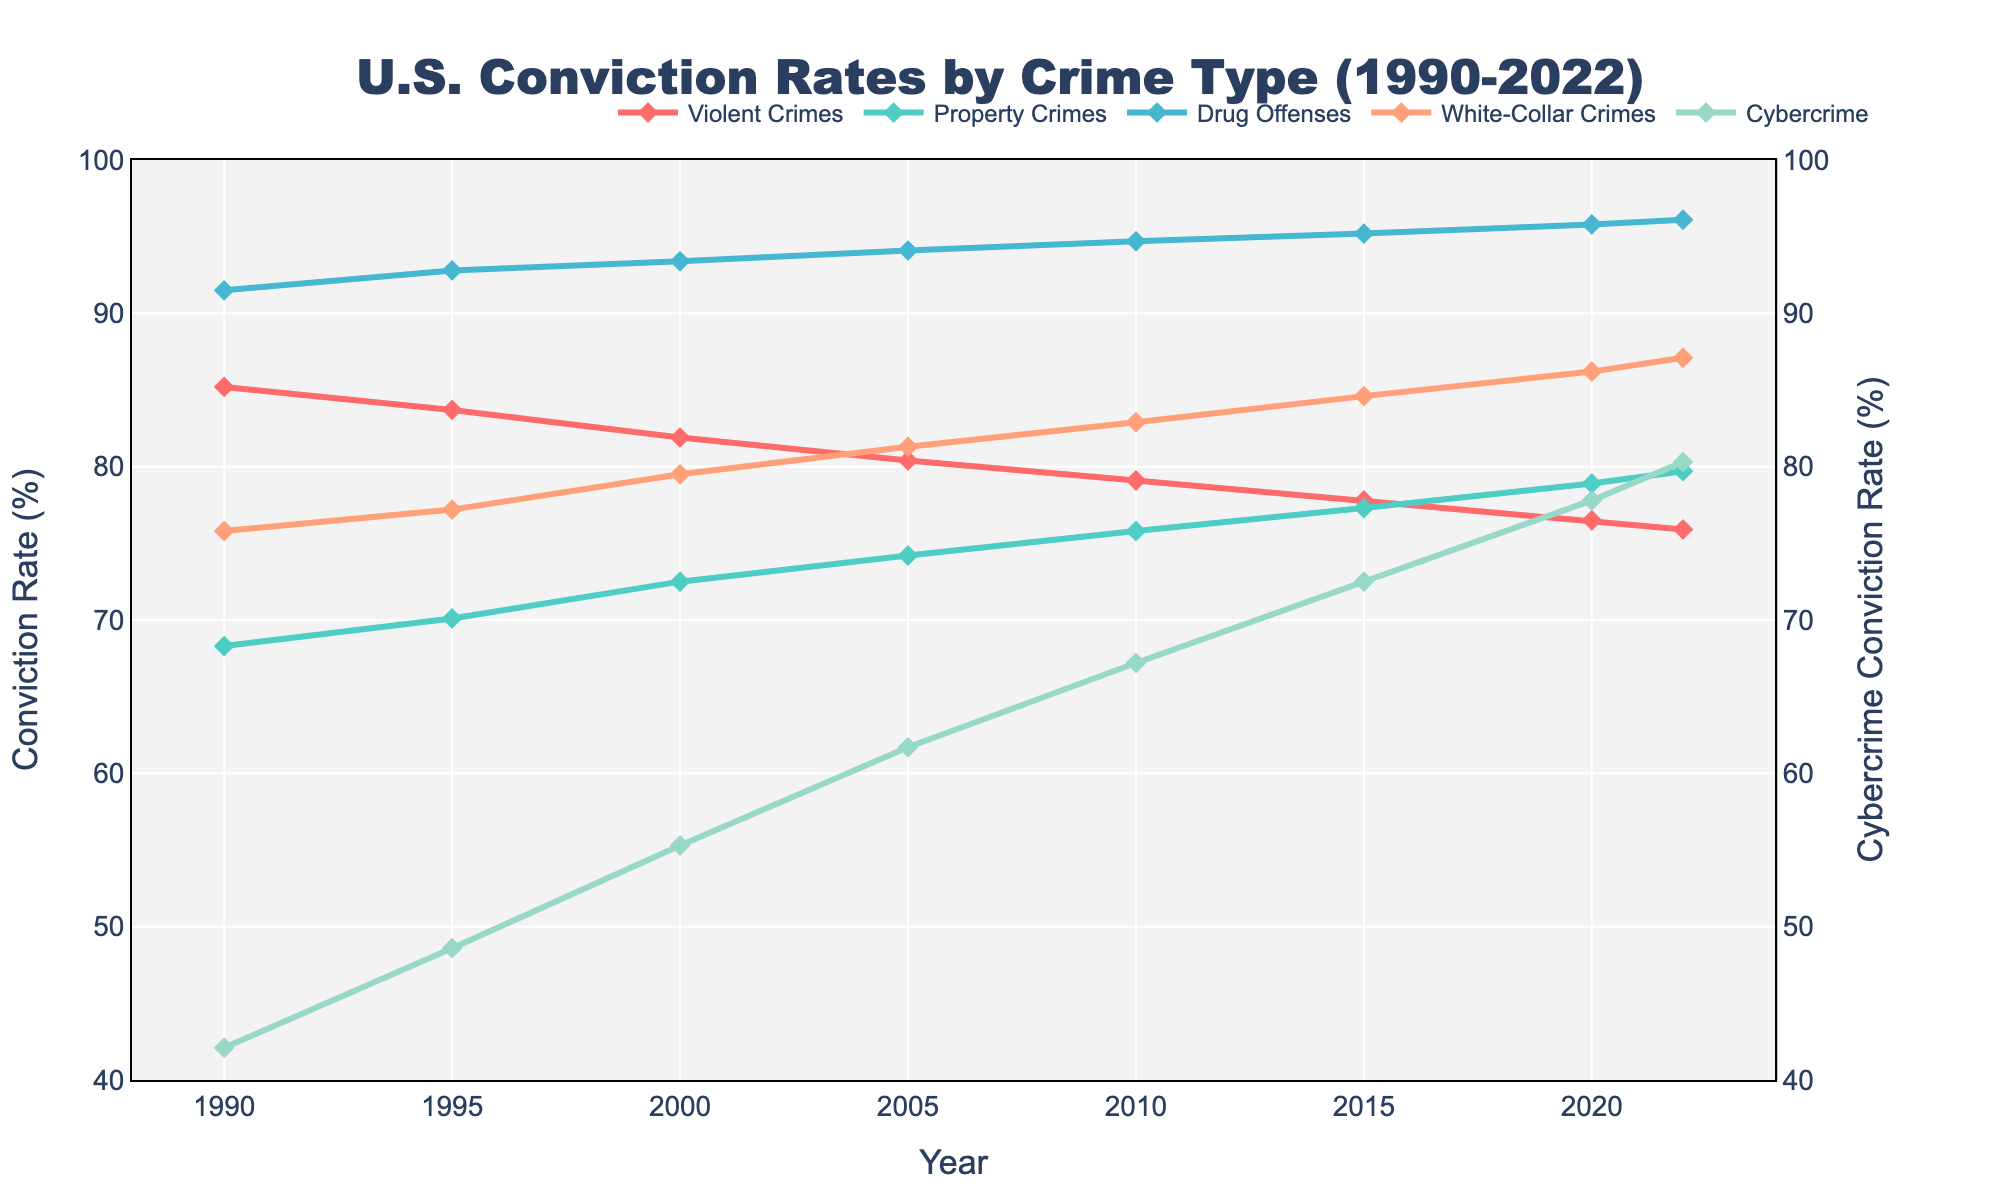How has the conviction rate for violent crimes changed from 1990 to 2022? From the chart, locate the line representing violent crimes and observe the change in height from the year 1990 to the year 2022. The rate starts at 85.2% in 1990 and gradually decreases to 75.9% in 2022.
Answer: Decreased Which type of crime had the highest conviction rate in 2022? Examine the end points of each line in the chart for the year 2022 and note the highest value. The conviction rates in 2022 were 75.9% for violent crimes, 79.7% for property crimes, 96.1% for drug offenses, 87.1% for white-collar crimes, and 80.3% for cybercrime.
Answer: Drug offenses What is the difference between the conviction rates of drug offenses and cybercrime in 2022? Look at the conviction rates for drug offenses and cybercrime in 2022. Drug offenses have a rate of 96.1% and cybercrime has 80.3%. Subtract 80.3% from 96.1%.
Answer: 15.8% How did the conviction rate for property crimes change between 1990 and 2022? Observe the line representing property crimes from 1990 to 2022. In 1990, it started at 68.3% and rose to 79.7% in 2022.
Answer: Increased Are the trends of conviction rates for white-collar crimes and cybercrime similar from 1990 to 2022? Compare the lines for white-collar crimes and cybercrime over the years. Both lines show an upward trend, indicating increasing conviction rates.
Answer: Yes What is the average conviction rate for violent crimes between 1990 and 2022? Identify the conviction rates for violent crimes in all years: 85.2, 83.7, 81.9, 80.4, 79.1, 77.8, 76.5, 75.9. Sum these values and divide by the number of data points (8). The sum is 640.5, and the average is 640.5/8.
Answer: 80.06% Which crime type had the smallest increase in conviction rate from 1990 to 2022? Calculate the increase in conviction rates for each crime type by subtracting the 1990 rate from the 2022 rate. Violent crimes: -9.3, Property crimes: 11.4, Drug offenses: 4.6, White-collar crimes: 11.3, Cybercrime: 38.2.
Answer: Violent crimes with a decrease, otherwise Drug offenses with the smallest increase What can you infer about the trend in cybercrime conviction rates over the years displayed? Observe the visual trend line for cybercrime from 1990 to 2022. The line shows a sharp increase, starting at 42.1% in 1990 and rising to 80.3% in 2022.
Answer: Increasing 